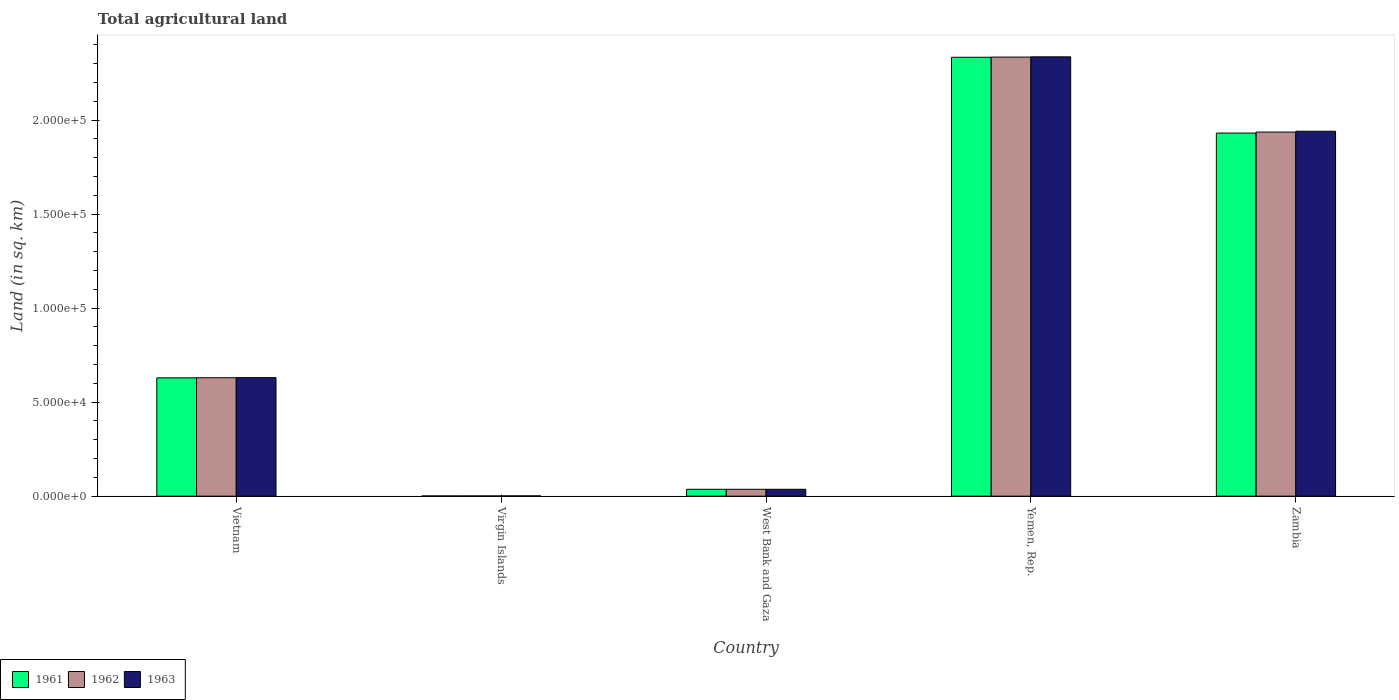Are the number of bars on each tick of the X-axis equal?
Your response must be concise. Yes. How many bars are there on the 3rd tick from the left?
Your answer should be compact. 3. How many bars are there on the 3rd tick from the right?
Keep it short and to the point. 3. What is the label of the 2nd group of bars from the left?
Keep it short and to the point. Virgin Islands. In how many cases, is the number of bars for a given country not equal to the number of legend labels?
Ensure brevity in your answer.  0. What is the total agricultural land in 1962 in Yemen, Rep.?
Offer a terse response. 2.33e+05. Across all countries, what is the maximum total agricultural land in 1963?
Make the answer very short. 2.34e+05. Across all countries, what is the minimum total agricultural land in 1963?
Your answer should be very brief. 140. In which country was the total agricultural land in 1963 maximum?
Provide a succinct answer. Yemen, Rep. In which country was the total agricultural land in 1961 minimum?
Your response must be concise. Virgin Islands. What is the total total agricultural land in 1961 in the graph?
Ensure brevity in your answer.  4.93e+05. What is the difference between the total agricultural land in 1963 in Vietnam and that in Virgin Islands?
Your answer should be compact. 6.29e+04. What is the difference between the total agricultural land in 1962 in Virgin Islands and the total agricultural land in 1961 in Yemen, Rep.?
Offer a very short reply. -2.33e+05. What is the average total agricultural land in 1962 per country?
Offer a very short reply. 9.88e+04. What is the ratio of the total agricultural land in 1961 in Vietnam to that in Zambia?
Your response must be concise. 0.33. Is the total agricultural land in 1962 in Vietnam less than that in Zambia?
Offer a very short reply. Yes. What is the difference between the highest and the second highest total agricultural land in 1962?
Give a very brief answer. 1.71e+05. What is the difference between the highest and the lowest total agricultural land in 1961?
Offer a terse response. 2.33e+05. What does the 3rd bar from the left in Virgin Islands represents?
Offer a very short reply. 1963. How many bars are there?
Give a very brief answer. 15. Are all the bars in the graph horizontal?
Make the answer very short. No. How many countries are there in the graph?
Give a very brief answer. 5. Does the graph contain grids?
Offer a very short reply. No. What is the title of the graph?
Ensure brevity in your answer.  Total agricultural land. Does "2000" appear as one of the legend labels in the graph?
Your answer should be very brief. No. What is the label or title of the Y-axis?
Your response must be concise. Land (in sq. km). What is the Land (in sq. km) of 1961 in Vietnam?
Ensure brevity in your answer.  6.29e+04. What is the Land (in sq. km) in 1962 in Vietnam?
Give a very brief answer. 6.30e+04. What is the Land (in sq. km) in 1963 in Vietnam?
Your response must be concise. 6.30e+04. What is the Land (in sq. km) of 1961 in Virgin Islands?
Offer a terse response. 120. What is the Land (in sq. km) of 1962 in Virgin Islands?
Provide a short and direct response. 120. What is the Land (in sq. km) in 1963 in Virgin Islands?
Make the answer very short. 140. What is the Land (in sq. km) of 1961 in West Bank and Gaza?
Give a very brief answer. 3660. What is the Land (in sq. km) of 1962 in West Bank and Gaza?
Offer a very short reply. 3660. What is the Land (in sq. km) of 1963 in West Bank and Gaza?
Provide a short and direct response. 3660. What is the Land (in sq. km) of 1961 in Yemen, Rep.?
Keep it short and to the point. 2.33e+05. What is the Land (in sq. km) of 1962 in Yemen, Rep.?
Make the answer very short. 2.33e+05. What is the Land (in sq. km) in 1963 in Yemen, Rep.?
Provide a succinct answer. 2.34e+05. What is the Land (in sq. km) in 1961 in Zambia?
Provide a succinct answer. 1.93e+05. What is the Land (in sq. km) in 1962 in Zambia?
Offer a terse response. 1.94e+05. What is the Land (in sq. km) of 1963 in Zambia?
Keep it short and to the point. 1.94e+05. Across all countries, what is the maximum Land (in sq. km) of 1961?
Your response must be concise. 2.33e+05. Across all countries, what is the maximum Land (in sq. km) of 1962?
Your response must be concise. 2.33e+05. Across all countries, what is the maximum Land (in sq. km) in 1963?
Offer a very short reply. 2.34e+05. Across all countries, what is the minimum Land (in sq. km) of 1961?
Your response must be concise. 120. Across all countries, what is the minimum Land (in sq. km) in 1962?
Offer a terse response. 120. Across all countries, what is the minimum Land (in sq. km) of 1963?
Your response must be concise. 140. What is the total Land (in sq. km) of 1961 in the graph?
Offer a very short reply. 4.93e+05. What is the total Land (in sq. km) in 1962 in the graph?
Offer a very short reply. 4.94e+05. What is the total Land (in sq. km) of 1963 in the graph?
Your response must be concise. 4.94e+05. What is the difference between the Land (in sq. km) in 1961 in Vietnam and that in Virgin Islands?
Keep it short and to the point. 6.28e+04. What is the difference between the Land (in sq. km) of 1962 in Vietnam and that in Virgin Islands?
Your answer should be very brief. 6.28e+04. What is the difference between the Land (in sq. km) of 1963 in Vietnam and that in Virgin Islands?
Keep it short and to the point. 6.29e+04. What is the difference between the Land (in sq. km) in 1961 in Vietnam and that in West Bank and Gaza?
Your answer should be very brief. 5.93e+04. What is the difference between the Land (in sq. km) of 1962 in Vietnam and that in West Bank and Gaza?
Ensure brevity in your answer.  5.93e+04. What is the difference between the Land (in sq. km) in 1963 in Vietnam and that in West Bank and Gaza?
Offer a terse response. 5.94e+04. What is the difference between the Land (in sq. km) in 1961 in Vietnam and that in Yemen, Rep.?
Your answer should be very brief. -1.70e+05. What is the difference between the Land (in sq. km) in 1962 in Vietnam and that in Yemen, Rep.?
Offer a terse response. -1.71e+05. What is the difference between the Land (in sq. km) of 1963 in Vietnam and that in Yemen, Rep.?
Give a very brief answer. -1.71e+05. What is the difference between the Land (in sq. km) of 1961 in Vietnam and that in Zambia?
Your answer should be compact. -1.30e+05. What is the difference between the Land (in sq. km) of 1962 in Vietnam and that in Zambia?
Ensure brevity in your answer.  -1.31e+05. What is the difference between the Land (in sq. km) in 1963 in Vietnam and that in Zambia?
Your response must be concise. -1.31e+05. What is the difference between the Land (in sq. km) in 1961 in Virgin Islands and that in West Bank and Gaza?
Make the answer very short. -3540. What is the difference between the Land (in sq. km) of 1962 in Virgin Islands and that in West Bank and Gaza?
Your answer should be very brief. -3540. What is the difference between the Land (in sq. km) of 1963 in Virgin Islands and that in West Bank and Gaza?
Your answer should be compact. -3520. What is the difference between the Land (in sq. km) of 1961 in Virgin Islands and that in Yemen, Rep.?
Make the answer very short. -2.33e+05. What is the difference between the Land (in sq. km) in 1962 in Virgin Islands and that in Yemen, Rep.?
Provide a short and direct response. -2.33e+05. What is the difference between the Land (in sq. km) in 1963 in Virgin Islands and that in Yemen, Rep.?
Provide a succinct answer. -2.33e+05. What is the difference between the Land (in sq. km) of 1961 in Virgin Islands and that in Zambia?
Offer a very short reply. -1.93e+05. What is the difference between the Land (in sq. km) of 1962 in Virgin Islands and that in Zambia?
Your response must be concise. -1.93e+05. What is the difference between the Land (in sq. km) of 1963 in Virgin Islands and that in Zambia?
Offer a terse response. -1.94e+05. What is the difference between the Land (in sq. km) in 1961 in West Bank and Gaza and that in Yemen, Rep.?
Provide a short and direct response. -2.30e+05. What is the difference between the Land (in sq. km) in 1962 in West Bank and Gaza and that in Yemen, Rep.?
Provide a short and direct response. -2.30e+05. What is the difference between the Land (in sq. km) in 1963 in West Bank and Gaza and that in Yemen, Rep.?
Provide a short and direct response. -2.30e+05. What is the difference between the Land (in sq. km) of 1961 in West Bank and Gaza and that in Zambia?
Your response must be concise. -1.89e+05. What is the difference between the Land (in sq. km) in 1962 in West Bank and Gaza and that in Zambia?
Your answer should be compact. -1.90e+05. What is the difference between the Land (in sq. km) in 1963 in West Bank and Gaza and that in Zambia?
Your answer should be compact. -1.90e+05. What is the difference between the Land (in sq. km) in 1961 in Yemen, Rep. and that in Zambia?
Your answer should be compact. 4.03e+04. What is the difference between the Land (in sq. km) of 1962 in Yemen, Rep. and that in Zambia?
Provide a short and direct response. 3.99e+04. What is the difference between the Land (in sq. km) of 1963 in Yemen, Rep. and that in Zambia?
Offer a terse response. 3.96e+04. What is the difference between the Land (in sq. km) of 1961 in Vietnam and the Land (in sq. km) of 1962 in Virgin Islands?
Make the answer very short. 6.28e+04. What is the difference between the Land (in sq. km) in 1961 in Vietnam and the Land (in sq. km) in 1963 in Virgin Islands?
Your response must be concise. 6.28e+04. What is the difference between the Land (in sq. km) of 1962 in Vietnam and the Land (in sq. km) of 1963 in Virgin Islands?
Provide a succinct answer. 6.28e+04. What is the difference between the Land (in sq. km) in 1961 in Vietnam and the Land (in sq. km) in 1962 in West Bank and Gaza?
Give a very brief answer. 5.93e+04. What is the difference between the Land (in sq. km) of 1961 in Vietnam and the Land (in sq. km) of 1963 in West Bank and Gaza?
Keep it short and to the point. 5.93e+04. What is the difference between the Land (in sq. km) in 1962 in Vietnam and the Land (in sq. km) in 1963 in West Bank and Gaza?
Offer a terse response. 5.93e+04. What is the difference between the Land (in sq. km) in 1961 in Vietnam and the Land (in sq. km) in 1962 in Yemen, Rep.?
Give a very brief answer. -1.71e+05. What is the difference between the Land (in sq. km) of 1961 in Vietnam and the Land (in sq. km) of 1963 in Yemen, Rep.?
Ensure brevity in your answer.  -1.71e+05. What is the difference between the Land (in sq. km) in 1962 in Vietnam and the Land (in sq. km) in 1963 in Yemen, Rep.?
Provide a short and direct response. -1.71e+05. What is the difference between the Land (in sq. km) in 1961 in Vietnam and the Land (in sq. km) in 1962 in Zambia?
Provide a short and direct response. -1.31e+05. What is the difference between the Land (in sq. km) of 1961 in Vietnam and the Land (in sq. km) of 1963 in Zambia?
Your answer should be very brief. -1.31e+05. What is the difference between the Land (in sq. km) of 1962 in Vietnam and the Land (in sq. km) of 1963 in Zambia?
Make the answer very short. -1.31e+05. What is the difference between the Land (in sq. km) of 1961 in Virgin Islands and the Land (in sq. km) of 1962 in West Bank and Gaza?
Offer a terse response. -3540. What is the difference between the Land (in sq. km) in 1961 in Virgin Islands and the Land (in sq. km) in 1963 in West Bank and Gaza?
Give a very brief answer. -3540. What is the difference between the Land (in sq. km) in 1962 in Virgin Islands and the Land (in sq. km) in 1963 in West Bank and Gaza?
Your response must be concise. -3540. What is the difference between the Land (in sq. km) in 1961 in Virgin Islands and the Land (in sq. km) in 1962 in Yemen, Rep.?
Your response must be concise. -2.33e+05. What is the difference between the Land (in sq. km) in 1961 in Virgin Islands and the Land (in sq. km) in 1963 in Yemen, Rep.?
Your response must be concise. -2.33e+05. What is the difference between the Land (in sq. km) in 1962 in Virgin Islands and the Land (in sq. km) in 1963 in Yemen, Rep.?
Provide a short and direct response. -2.33e+05. What is the difference between the Land (in sq. km) in 1961 in Virgin Islands and the Land (in sq. km) in 1962 in Zambia?
Give a very brief answer. -1.93e+05. What is the difference between the Land (in sq. km) in 1961 in Virgin Islands and the Land (in sq. km) in 1963 in Zambia?
Provide a succinct answer. -1.94e+05. What is the difference between the Land (in sq. km) in 1962 in Virgin Islands and the Land (in sq. km) in 1963 in Zambia?
Your answer should be very brief. -1.94e+05. What is the difference between the Land (in sq. km) of 1961 in West Bank and Gaza and the Land (in sq. km) of 1962 in Yemen, Rep.?
Your response must be concise. -2.30e+05. What is the difference between the Land (in sq. km) of 1961 in West Bank and Gaza and the Land (in sq. km) of 1963 in Yemen, Rep.?
Make the answer very short. -2.30e+05. What is the difference between the Land (in sq. km) of 1962 in West Bank and Gaza and the Land (in sq. km) of 1963 in Yemen, Rep.?
Keep it short and to the point. -2.30e+05. What is the difference between the Land (in sq. km) in 1961 in West Bank and Gaza and the Land (in sq. km) in 1962 in Zambia?
Your response must be concise. -1.90e+05. What is the difference between the Land (in sq. km) in 1961 in West Bank and Gaza and the Land (in sq. km) in 1963 in Zambia?
Provide a short and direct response. -1.90e+05. What is the difference between the Land (in sq. km) in 1962 in West Bank and Gaza and the Land (in sq. km) in 1963 in Zambia?
Offer a very short reply. -1.90e+05. What is the difference between the Land (in sq. km) in 1961 in Yemen, Rep. and the Land (in sq. km) in 1962 in Zambia?
Provide a succinct answer. 3.98e+04. What is the difference between the Land (in sq. km) in 1961 in Yemen, Rep. and the Land (in sq. km) in 1963 in Zambia?
Your answer should be compact. 3.93e+04. What is the difference between the Land (in sq. km) in 1962 in Yemen, Rep. and the Land (in sq. km) in 1963 in Zambia?
Give a very brief answer. 3.94e+04. What is the average Land (in sq. km) of 1961 per country?
Provide a short and direct response. 9.86e+04. What is the average Land (in sq. km) of 1962 per country?
Your answer should be very brief. 9.88e+04. What is the average Land (in sq. km) of 1963 per country?
Give a very brief answer. 9.89e+04. What is the difference between the Land (in sq. km) of 1961 and Land (in sq. km) of 1962 in Vietnam?
Your answer should be compact. -50. What is the difference between the Land (in sq. km) of 1961 and Land (in sq. km) of 1963 in Vietnam?
Your answer should be compact. -100. What is the difference between the Land (in sq. km) in 1962 and Land (in sq. km) in 1963 in Vietnam?
Make the answer very short. -50. What is the difference between the Land (in sq. km) of 1961 and Land (in sq. km) of 1963 in West Bank and Gaza?
Offer a terse response. 0. What is the difference between the Land (in sq. km) in 1961 and Land (in sq. km) in 1962 in Yemen, Rep.?
Provide a short and direct response. -110. What is the difference between the Land (in sq. km) of 1961 and Land (in sq. km) of 1963 in Yemen, Rep.?
Offer a very short reply. -230. What is the difference between the Land (in sq. km) in 1962 and Land (in sq. km) in 1963 in Yemen, Rep.?
Your answer should be compact. -120. What is the difference between the Land (in sq. km) in 1961 and Land (in sq. km) in 1962 in Zambia?
Your answer should be compact. -530. What is the difference between the Land (in sq. km) in 1961 and Land (in sq. km) in 1963 in Zambia?
Offer a very short reply. -970. What is the difference between the Land (in sq. km) in 1962 and Land (in sq. km) in 1963 in Zambia?
Offer a terse response. -440. What is the ratio of the Land (in sq. km) in 1961 in Vietnam to that in Virgin Islands?
Your answer should be very brief. 524.33. What is the ratio of the Land (in sq. km) in 1962 in Vietnam to that in Virgin Islands?
Your answer should be compact. 524.75. What is the ratio of the Land (in sq. km) of 1963 in Vietnam to that in Virgin Islands?
Offer a very short reply. 450.14. What is the ratio of the Land (in sq. km) of 1961 in Vietnam to that in West Bank and Gaza?
Your answer should be compact. 17.19. What is the ratio of the Land (in sq. km) of 1962 in Vietnam to that in West Bank and Gaza?
Your answer should be compact. 17.2. What is the ratio of the Land (in sq. km) in 1963 in Vietnam to that in West Bank and Gaza?
Your answer should be compact. 17.22. What is the ratio of the Land (in sq. km) in 1961 in Vietnam to that in Yemen, Rep.?
Keep it short and to the point. 0.27. What is the ratio of the Land (in sq. km) of 1962 in Vietnam to that in Yemen, Rep.?
Offer a terse response. 0.27. What is the ratio of the Land (in sq. km) in 1963 in Vietnam to that in Yemen, Rep.?
Provide a succinct answer. 0.27. What is the ratio of the Land (in sq. km) in 1961 in Vietnam to that in Zambia?
Offer a very short reply. 0.33. What is the ratio of the Land (in sq. km) of 1962 in Vietnam to that in Zambia?
Offer a terse response. 0.33. What is the ratio of the Land (in sq. km) in 1963 in Vietnam to that in Zambia?
Keep it short and to the point. 0.32. What is the ratio of the Land (in sq. km) in 1961 in Virgin Islands to that in West Bank and Gaza?
Your answer should be compact. 0.03. What is the ratio of the Land (in sq. km) of 1962 in Virgin Islands to that in West Bank and Gaza?
Your response must be concise. 0.03. What is the ratio of the Land (in sq. km) in 1963 in Virgin Islands to that in West Bank and Gaza?
Offer a terse response. 0.04. What is the ratio of the Land (in sq. km) of 1961 in Virgin Islands to that in Yemen, Rep.?
Make the answer very short. 0. What is the ratio of the Land (in sq. km) in 1963 in Virgin Islands to that in Yemen, Rep.?
Make the answer very short. 0. What is the ratio of the Land (in sq. km) of 1961 in Virgin Islands to that in Zambia?
Keep it short and to the point. 0. What is the ratio of the Land (in sq. km) in 1962 in Virgin Islands to that in Zambia?
Your answer should be very brief. 0. What is the ratio of the Land (in sq. km) in 1963 in Virgin Islands to that in Zambia?
Your answer should be very brief. 0. What is the ratio of the Land (in sq. km) in 1961 in West Bank and Gaza to that in Yemen, Rep.?
Offer a terse response. 0.02. What is the ratio of the Land (in sq. km) of 1962 in West Bank and Gaza to that in Yemen, Rep.?
Provide a succinct answer. 0.02. What is the ratio of the Land (in sq. km) in 1963 in West Bank and Gaza to that in Yemen, Rep.?
Make the answer very short. 0.02. What is the ratio of the Land (in sq. km) in 1961 in West Bank and Gaza to that in Zambia?
Give a very brief answer. 0.02. What is the ratio of the Land (in sq. km) in 1962 in West Bank and Gaza to that in Zambia?
Offer a terse response. 0.02. What is the ratio of the Land (in sq. km) of 1963 in West Bank and Gaza to that in Zambia?
Ensure brevity in your answer.  0.02. What is the ratio of the Land (in sq. km) of 1961 in Yemen, Rep. to that in Zambia?
Your response must be concise. 1.21. What is the ratio of the Land (in sq. km) in 1962 in Yemen, Rep. to that in Zambia?
Make the answer very short. 1.21. What is the ratio of the Land (in sq. km) in 1963 in Yemen, Rep. to that in Zambia?
Your answer should be compact. 1.2. What is the difference between the highest and the second highest Land (in sq. km) of 1961?
Make the answer very short. 4.03e+04. What is the difference between the highest and the second highest Land (in sq. km) in 1962?
Provide a succinct answer. 3.99e+04. What is the difference between the highest and the second highest Land (in sq. km) of 1963?
Ensure brevity in your answer.  3.96e+04. What is the difference between the highest and the lowest Land (in sq. km) in 1961?
Your response must be concise. 2.33e+05. What is the difference between the highest and the lowest Land (in sq. km) in 1962?
Provide a succinct answer. 2.33e+05. What is the difference between the highest and the lowest Land (in sq. km) in 1963?
Offer a terse response. 2.33e+05. 